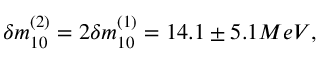<formula> <loc_0><loc_0><loc_500><loc_500>\delta m _ { 1 0 } ^ { ( 2 ) } = 2 \delta m _ { 1 0 } ^ { ( 1 ) } = 1 4 . 1 \pm 5 . 1 M e V ,</formula> 